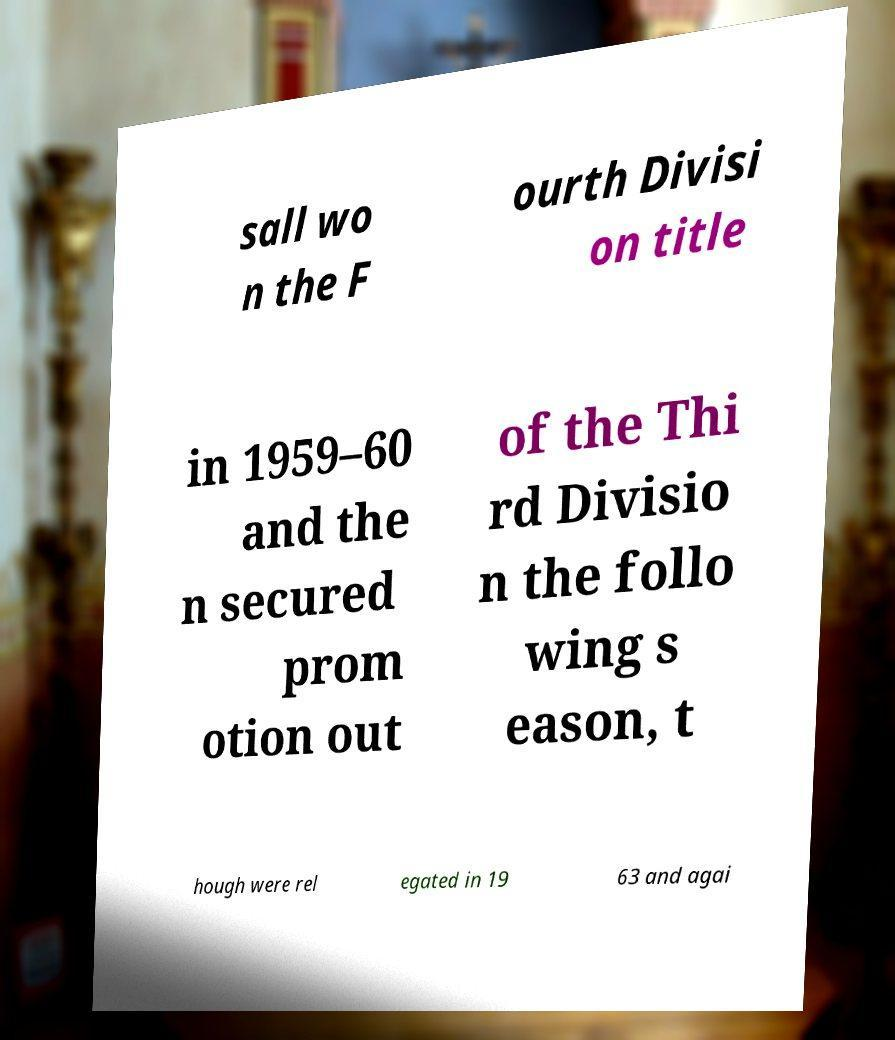Could you assist in decoding the text presented in this image and type it out clearly? sall wo n the F ourth Divisi on title in 1959–60 and the n secured prom otion out of the Thi rd Divisio n the follo wing s eason, t hough were rel egated in 19 63 and agai 